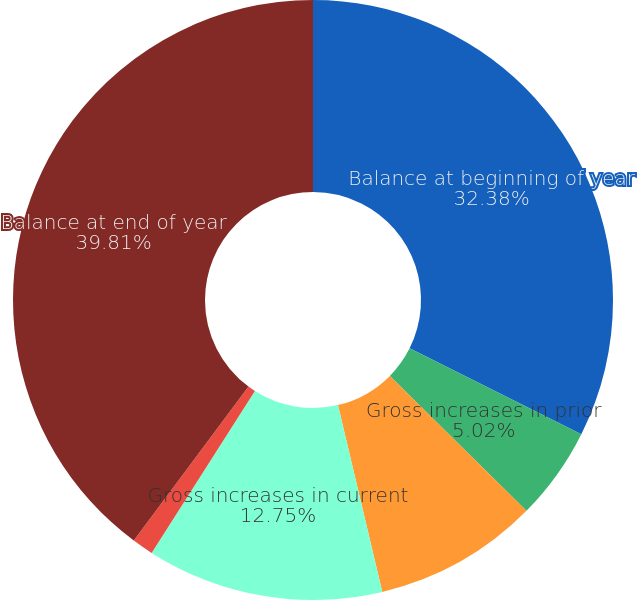Convert chart. <chart><loc_0><loc_0><loc_500><loc_500><pie_chart><fcel>Balance at beginning of year<fcel>Gross increases in prior<fcel>Gross decreases in prior<fcel>Gross increases in current<fcel>Decreases from the expiration<fcel>Balance at end of year<nl><fcel>32.38%<fcel>5.02%<fcel>8.89%<fcel>12.75%<fcel>1.15%<fcel>39.81%<nl></chart> 